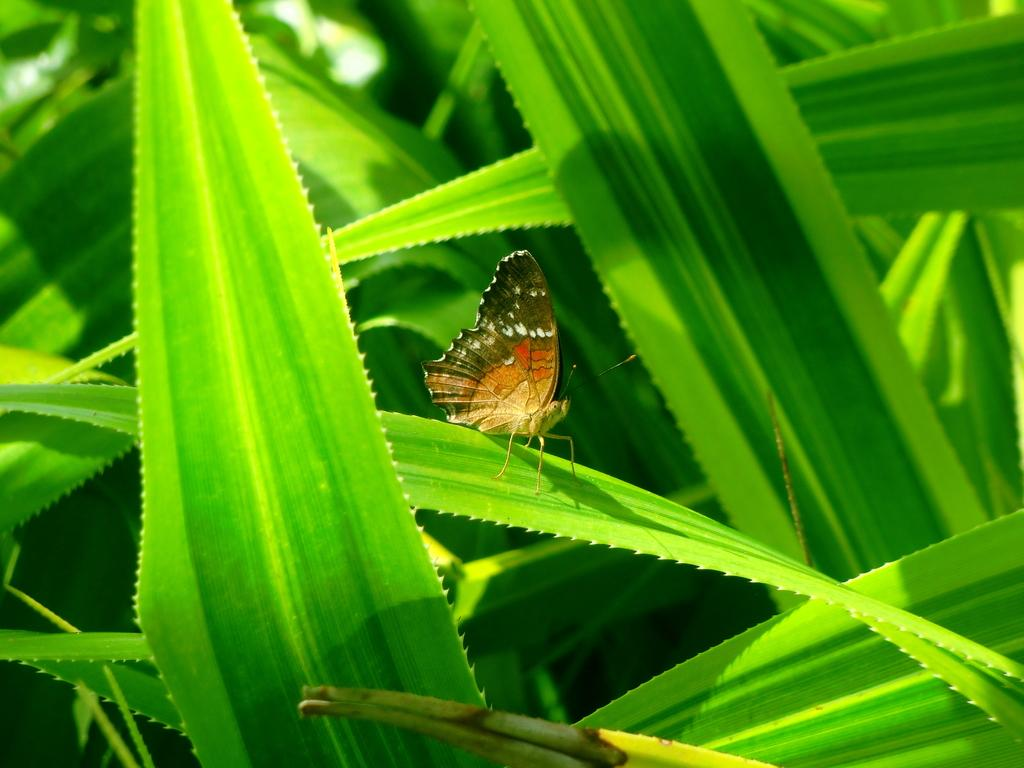What is the main subject of the image? There is a butterfly in the image. Where is the butterfly located? The butterfly is on a leaf. What else can be seen in the image besides the butterfly? There are plants in the image. What type of paper can be seen in the image? There is no paper present in the image; it features a butterfly on a leaf and plants. What sound does the alarm make in the image? There is no alarm present in the image, so it cannot make any sound. 